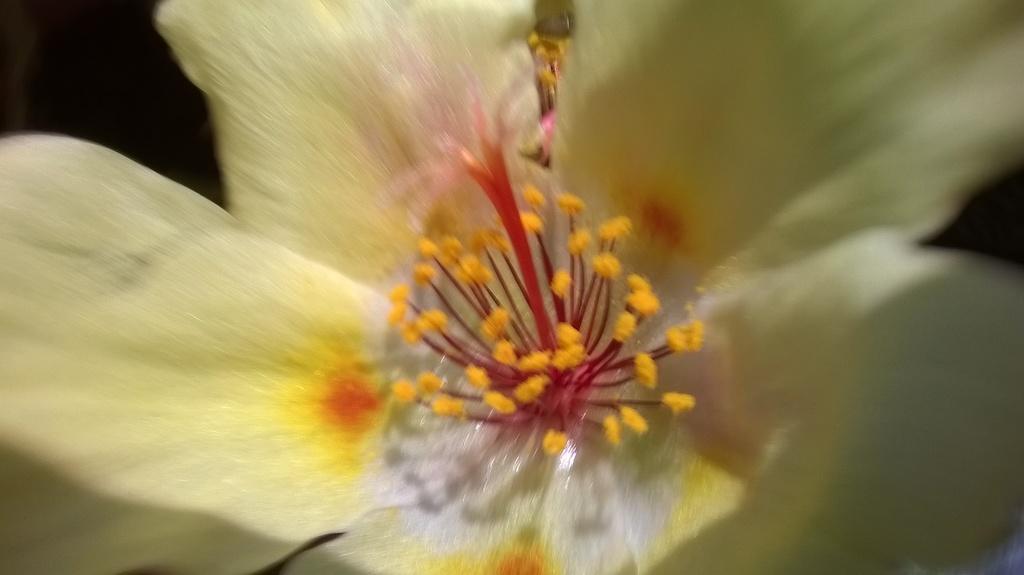How would you summarize this image in a sentence or two? In the image there is a flower. 